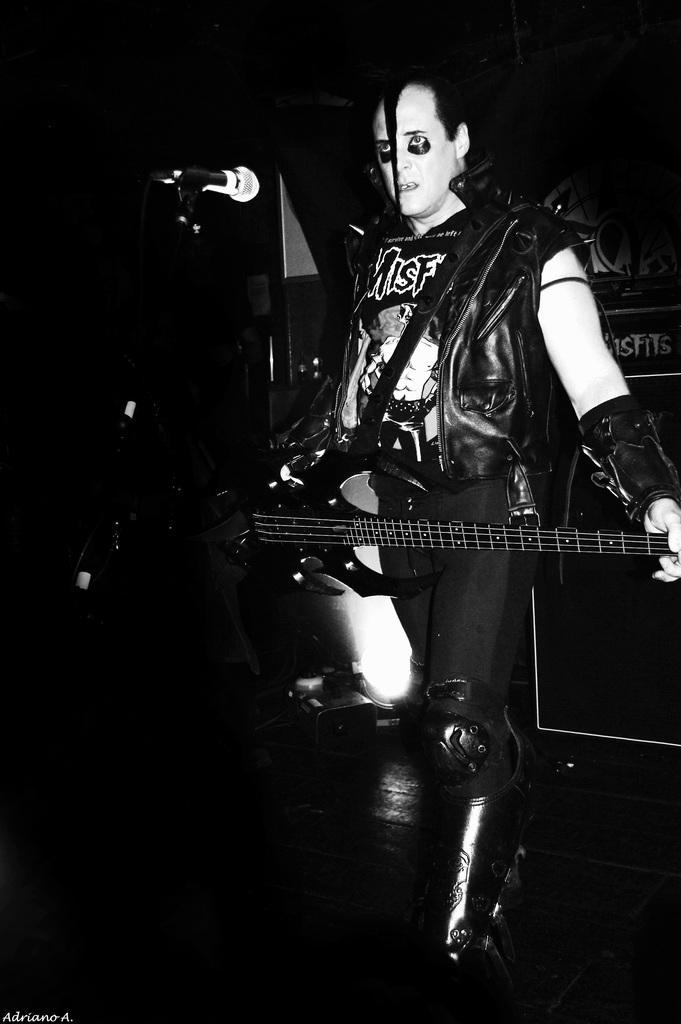What is the color scheme of the image? The image is black and white. What is the man in the image doing? The man is standing and holding a guitar. What equipment is present in the image related to music? There is a microphone with a stand and a speaker box in the image. What type of lighting is visible in the image? There is a light in the image. What type of ball is being used in the picture? There is no ball present in the image. What is the subject of the picture within the picture? There is no picture within the picture, as the image is not mentioned to contain any. 